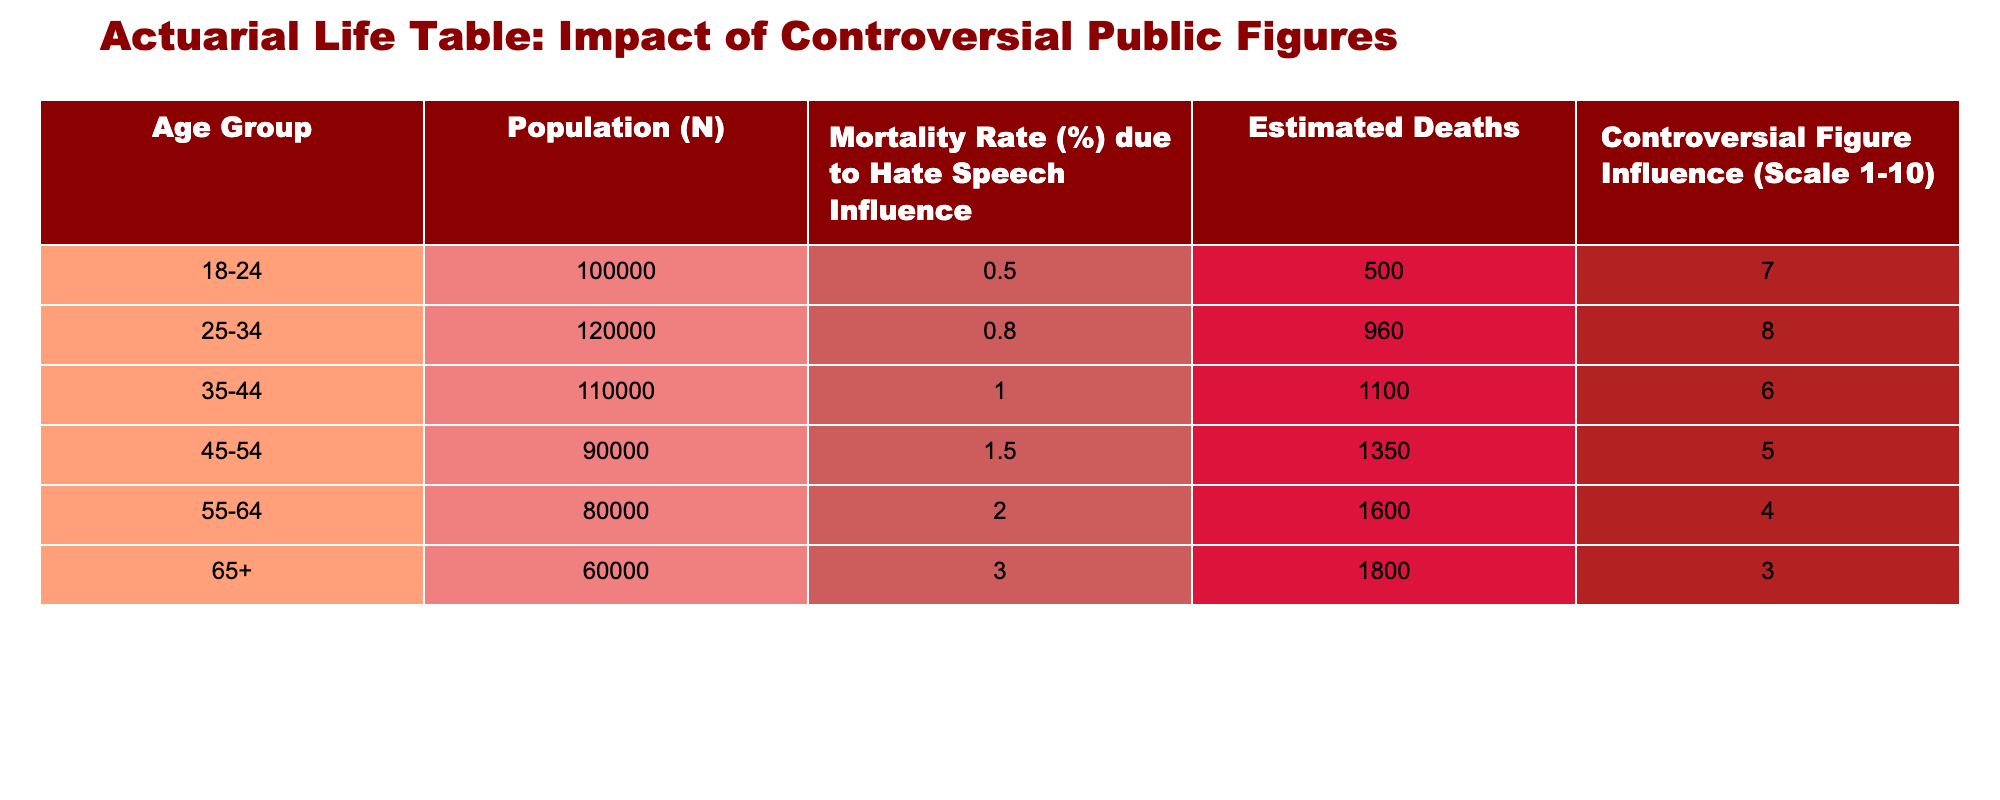What is the mortality rate for the age group 25-34? The mortality rate for the age group 25-34 is listed directly in the table under the "Mortality Rate (%) due to Hate Speech Influence" column as 0.8%.
Answer: 0.8% How many estimated deaths occur in the 55-64 age group? The estimated deaths for the 55-64 age group are found in the "Estimated Deaths" column, which shows a value of 1600.
Answer: 1600 Which age group has the highest controversial figure influence? By examining the "Controversial Figure Influence (Scale 1-10)" column, the age group with the highest score is 25-34, with a scale of 8.
Answer: 25-34 What is the total estimated deaths across all age groups? To find the total estimated deaths, sum the values in the "Estimated Deaths" column: 500 + 960 + 1100 + 1350 + 1600 + 1800 = 5410.
Answer: 5410 Is the mortality rate for age group 65+ greater than that for age group 45-54? Looking at the mortality rates, the 65+ group has a rate of 3.0%, while 45-54 has a rate of 1.5%. Thus, it is true that 3.0% is greater than 1.5%.
Answer: Yes What is the difference in estimated deaths between the age groups 35-44 and 55-64? The estimated deaths for 35-44 are 1100 and for 55-64 are 1600. The difference is calculated as 1600 - 1100 = 500.
Answer: 500 Which age group has the lowest population? In the "Population (N)" column, the age group with the lowest population is 65+ with a total of 60000.
Answer: 65+ What is the average mortality rate across all age groups? To find the average, add all the mortality rates: 0.5 + 0.8 + 1.0 + 1.5 + 2.0 + 3.0 = 9.8 and then divide by the number of groups (6), giving an average of 9.8 / 6 ≈ 1.63.
Answer: 1.63 Is the controversial figure influence for the age group 45-54 above a scale of 6? The "Controversial Figure Influence (Scale 1-10)" for the age group 45-54 is 5, which is not above a scale of 6, therefore the answer is no.
Answer: No What age group has a mortality rate below 1.0%? Looking at the table, the age groups with a mortality rate below 1.0% are 18-24 (0.5%) and 25-34 (0.8%).
Answer: 18-24, 25-34 